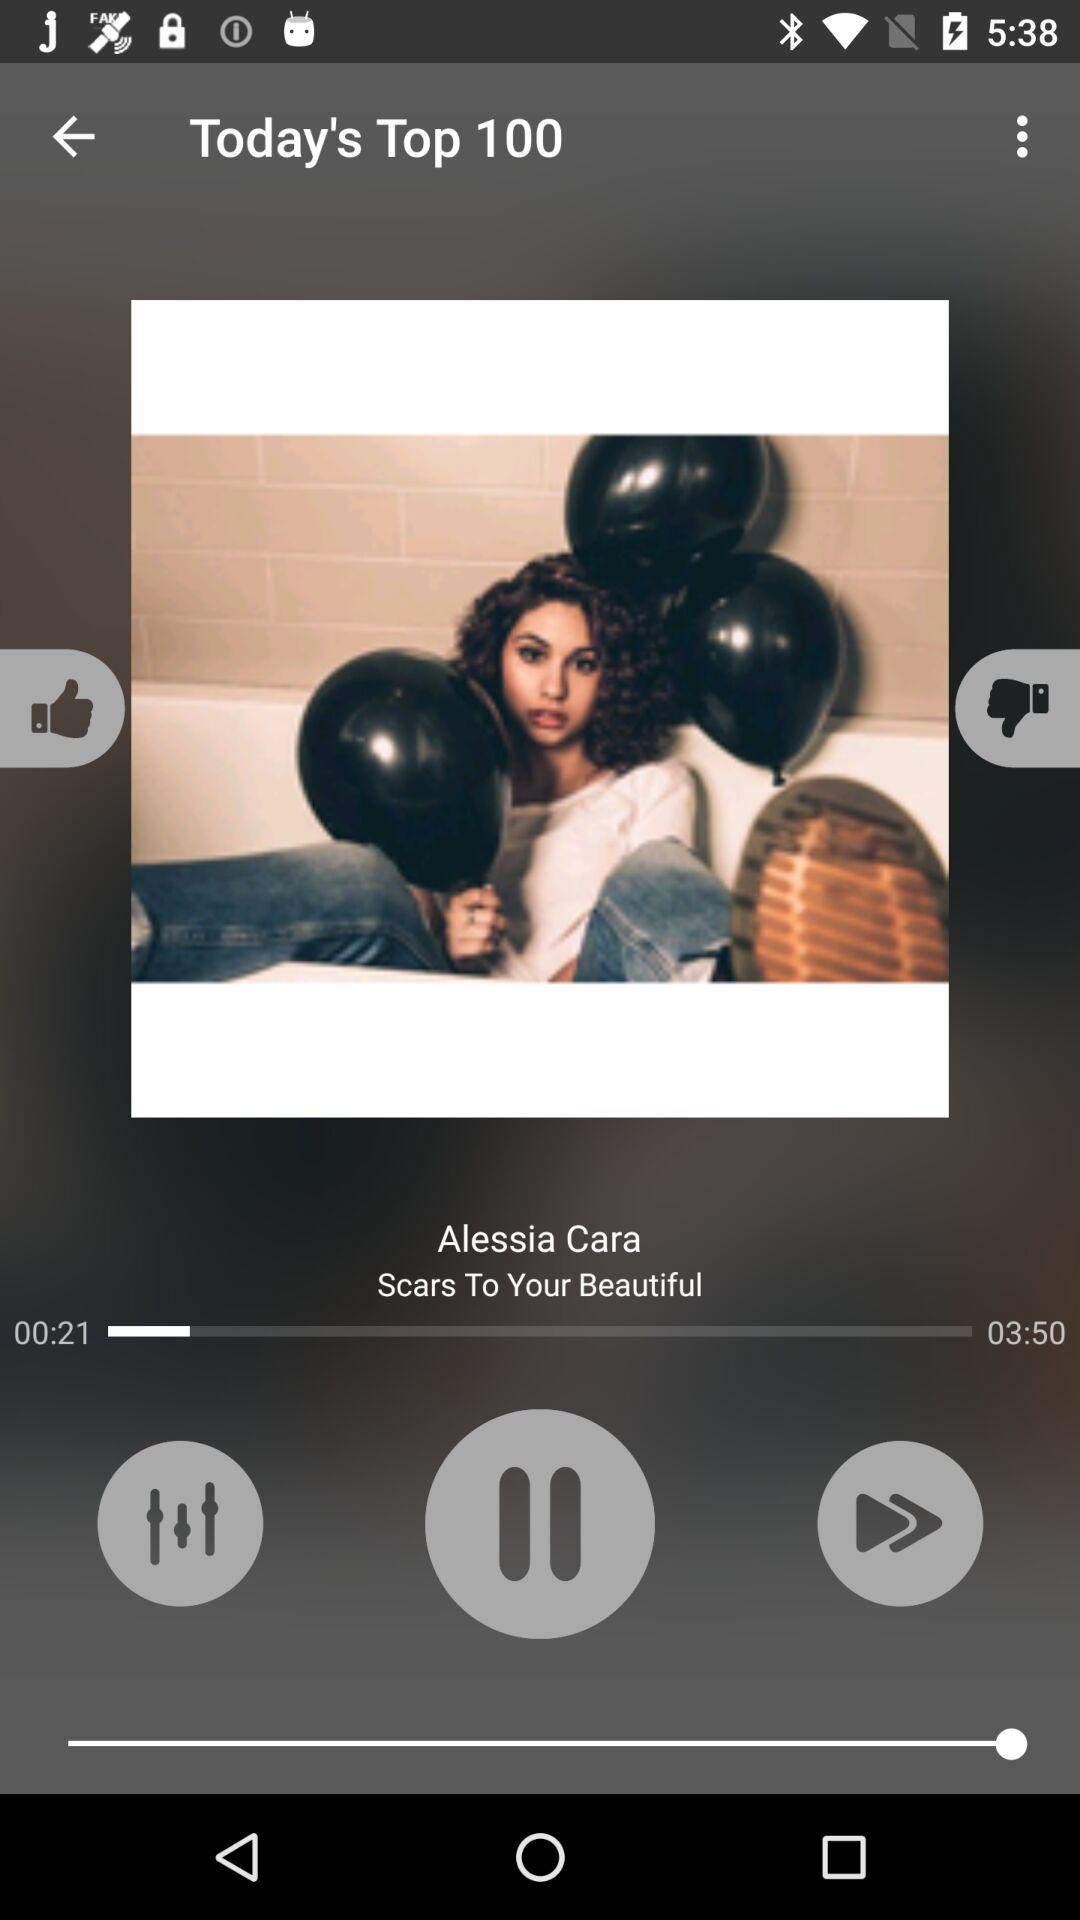What is the total duration of the song? The total duration of the song is 3 minutes and 50 seconds. 